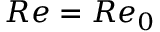<formula> <loc_0><loc_0><loc_500><loc_500>R e = R e _ { 0 }</formula> 